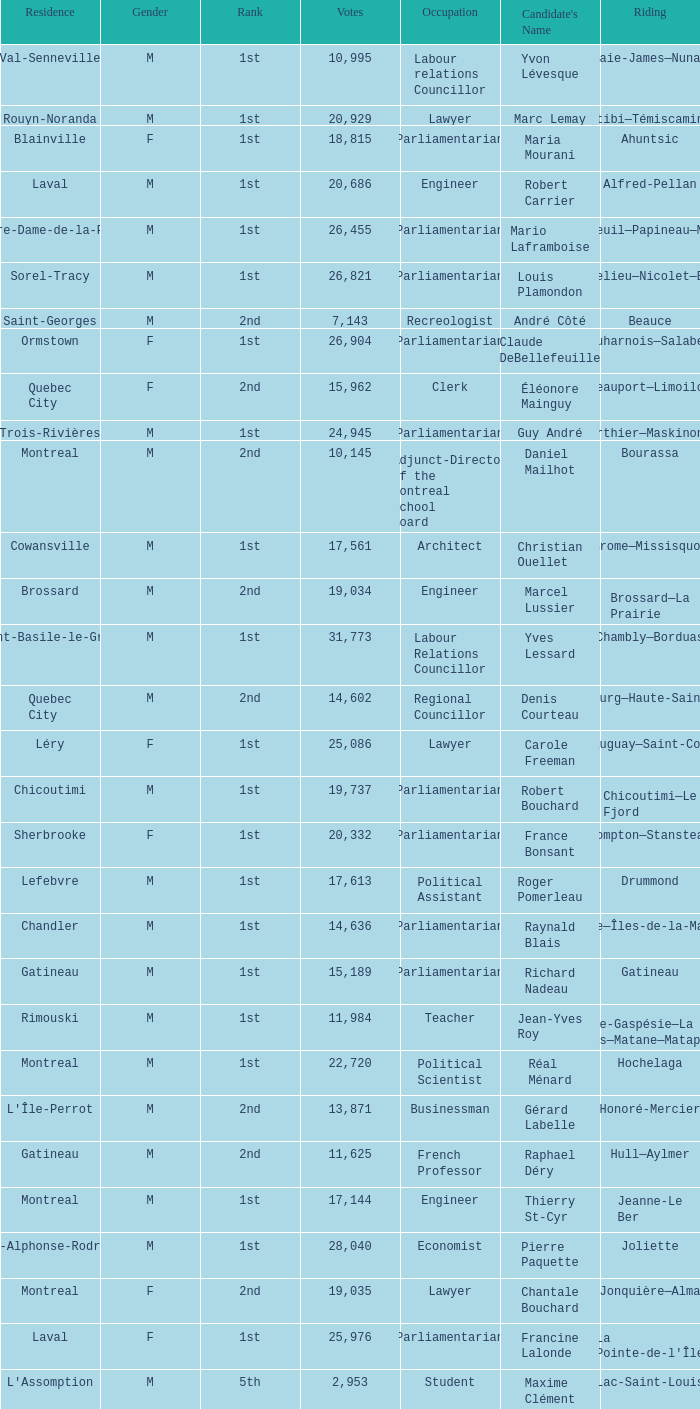What gender is Luc Desnoyers? M. 